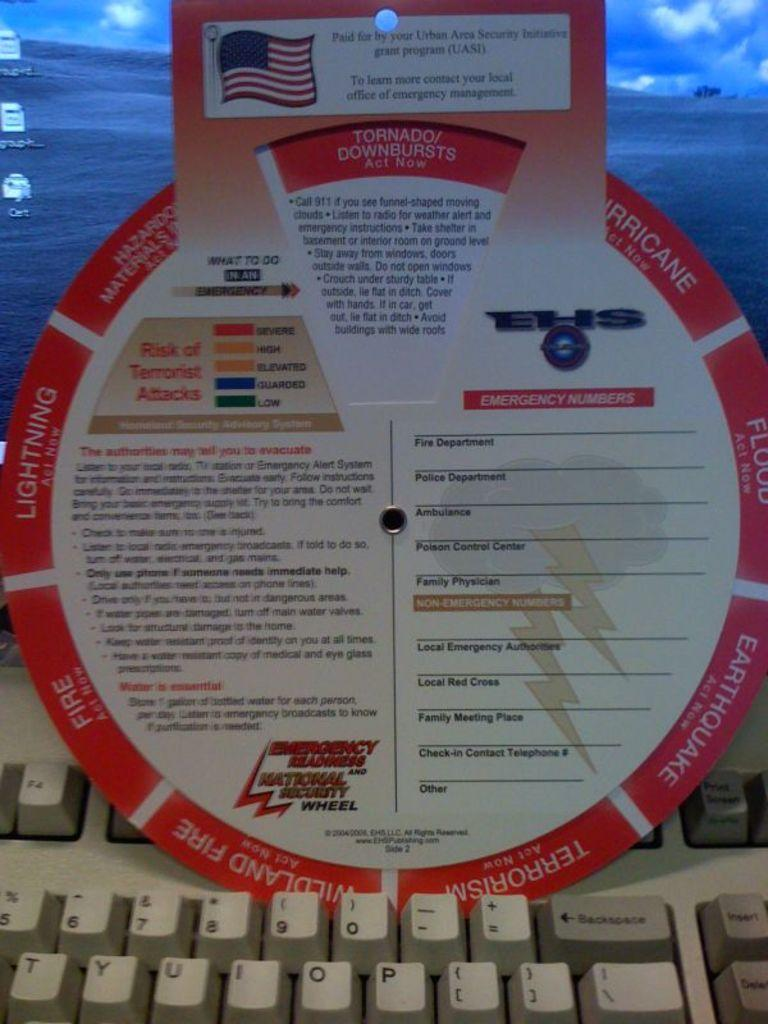Provide a one-sentence caption for the provided image. An emergency security wheel sitting on top of a computer keyboard. 